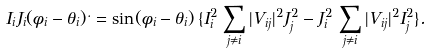<formula> <loc_0><loc_0><loc_500><loc_500>I _ { i } J _ { i } ( \phi _ { i } - \theta _ { i } ) ^ { . } = \sin ( \phi _ { i } - \theta _ { i } ) \, \{ I _ { i } ^ { 2 } \, \sum _ { j \neq i } | V _ { i j } | ^ { 2 } J _ { j } ^ { 2 } - J _ { i } ^ { 2 } \, \sum _ { j \neq i } | V _ { i j } | ^ { 2 } I _ { j } ^ { 2 } \} .</formula> 